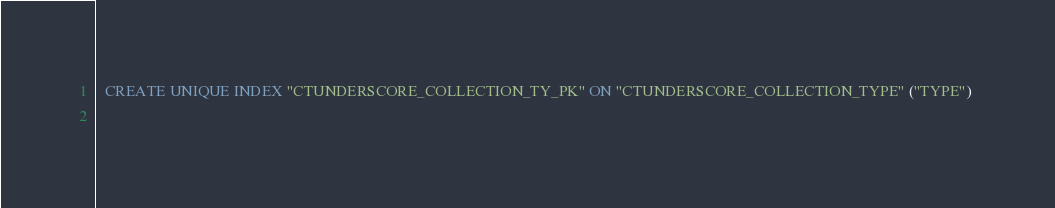Convert code to text. <code><loc_0><loc_0><loc_500><loc_500><_SQL_>
  CREATE UNIQUE INDEX "CTUNDERSCORE_COLLECTION_TY_PK" ON "CTUNDERSCORE_COLLECTION_TYPE" ("TYPE") 
  </code> 